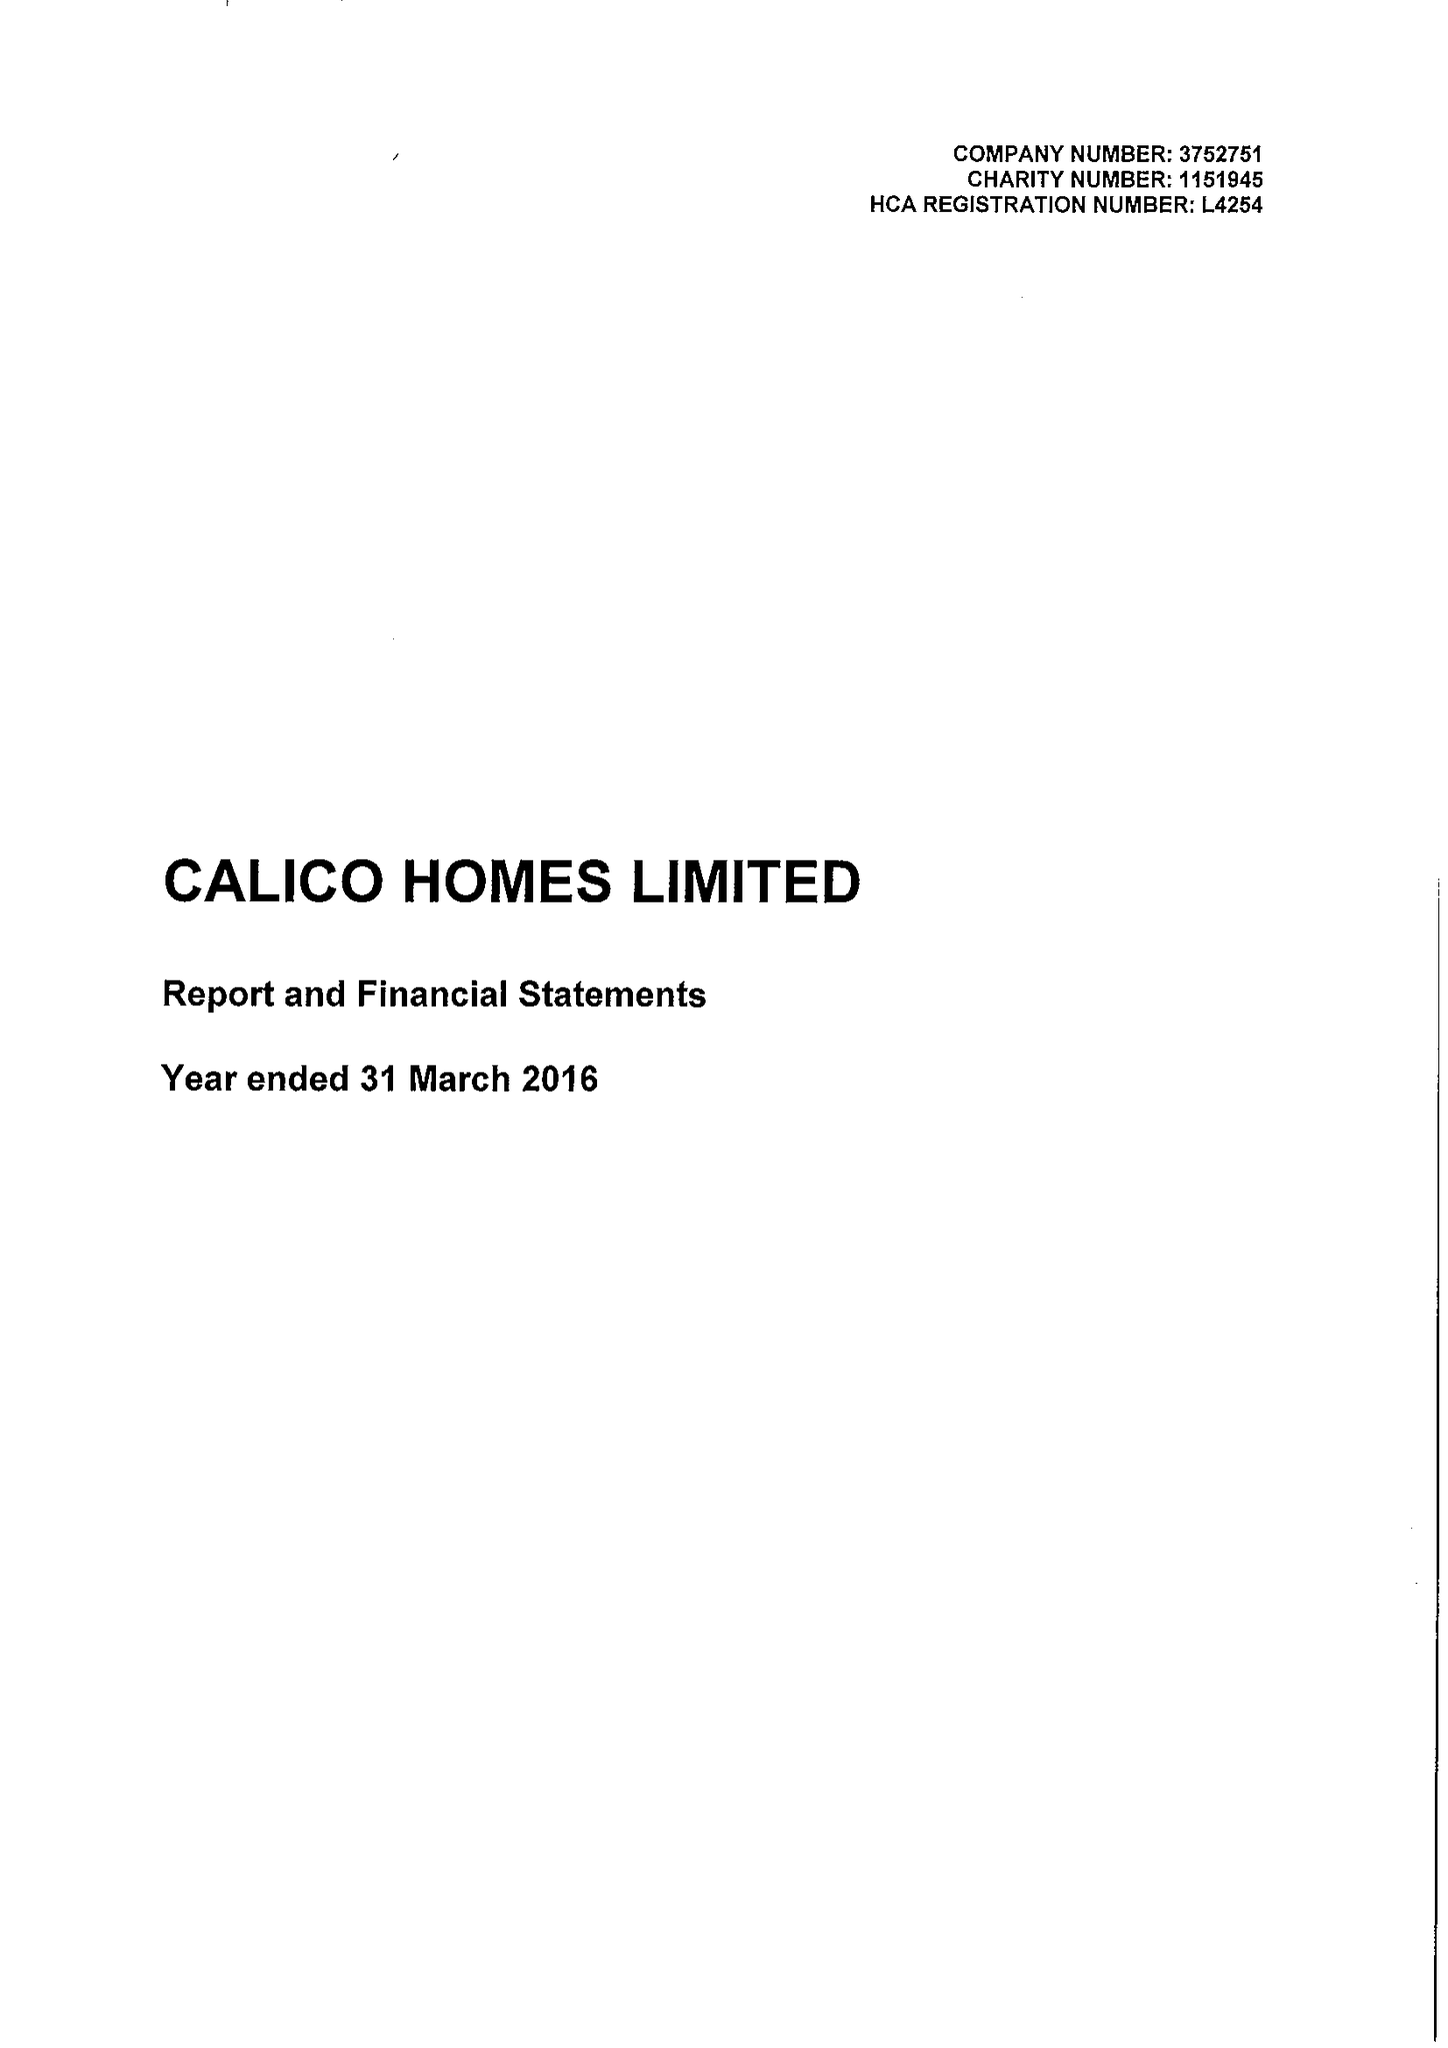What is the value for the report_date?
Answer the question using a single word or phrase. 2016-03-31 